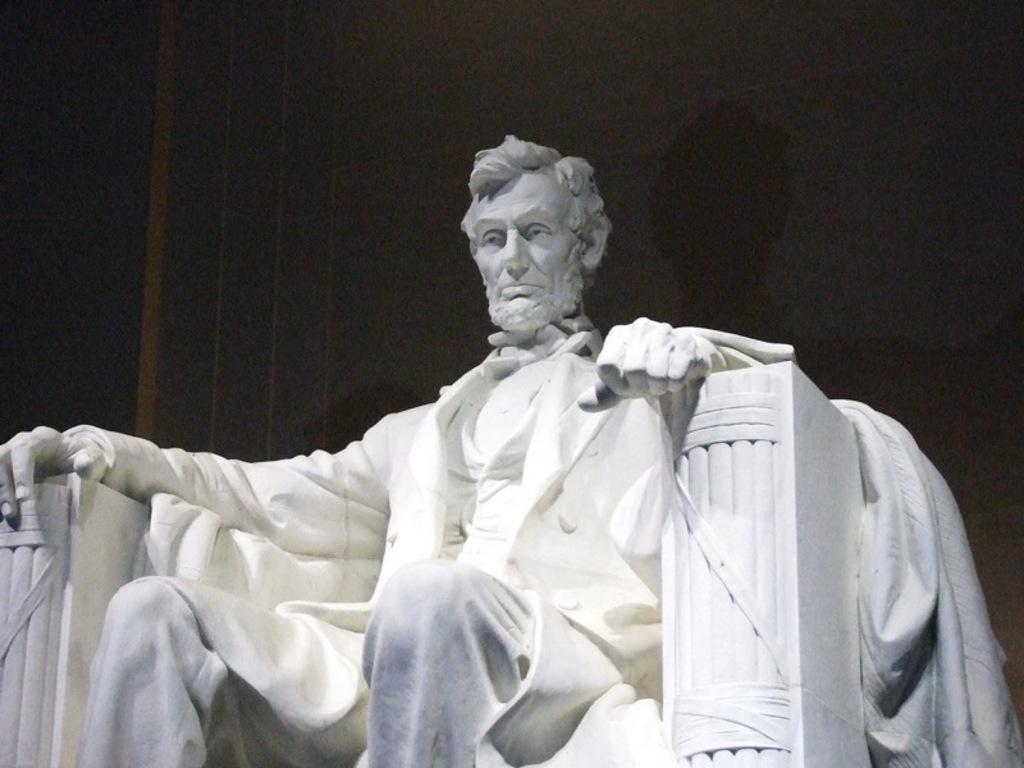Could you give a brief overview of what you see in this image? This image is taken indoors. In the background there is a wall. In the middle of the image there is a sculpture of a man. 